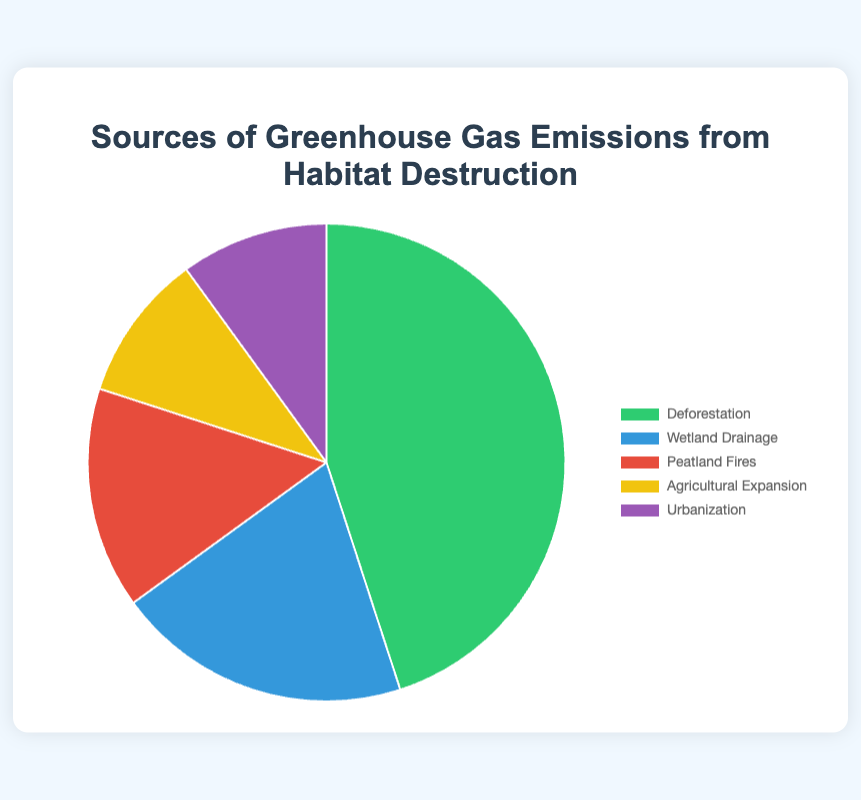Which source contributes the most to greenhouse gas emissions from habitat destruction? Look at the size of each section in the pie chart. The largest percentage corresponds to deforestation with 45%.
Answer: Deforestation How do emissions from wetland drainage compare to emissions from urbanization? Compare the percentages of the two sources. Wetland drainage is 20%, and urbanization is 10%. 20% is greater than 10%.
Answer: Wetland drainage is larger What is the combined percentage of emissions from agricultural expansion and urbanization? Add the percentages of agricultural expansion and urbanization. 10% + 10% = 20%.
Answer: 20% Is the percentage of emissions from peatland fires more or less than half of the percentage from deforestation? Half of deforestation's 45% is 22.5%. Peatland fires constitute 15%, which is less than 22.5%.
Answer: Less Which category, among the listed sources, contributes the least to the overall greenhouse gas emissions? Identify the smallest section in the pie chart. Both agricultural expansion and urbanization are 10%, but since they are equal, either can be considered the least.
Answer: Agricultural expansion or Urbanization By how much does the emission percentage from deforestation exceed the combined percentage of agricultural expansion and urbanization? The combined percentage of agricultural expansion and urbanization is 20%. The percentage for deforestation is 45%, and the difference is 45% - 20% = 25%.
Answer: 25% Does wetland drainage have a greater or lesser percentage of emissions than the sum of peatland fires and urbanization? The sum of peatland fires and urbanization is 15% + 10% = 25%. Wetland drainage by itself is 20%. Since 20% is less than 25%, it is lesser.
Answer: Lesser Which slice of the pie, represented by color, indicates the emission percentage for peatland fires? The color corresponding to peatland fires needs to be identified by looking at the chart description. The red section represents peatland fires.
Answer: Red What is the proportion, in percentage, of the emissions from agricultural expansion relative to the total emissions? Since the total is 100%, the percentage proportion of agricultural expansion is its own value. Agricultural expansion is 10%.
Answer: 10% If wetland drainage and urbanization emissions were combined into a single slice, would this new slice be larger than the deforestation slice? Combined slice value is 20% (wetland drainage) + 10% (urbanization) = 30%. Compare it to deforestation's 45%. Since 30% is less than 45%, the combined slice would not be larger.
Answer: No 